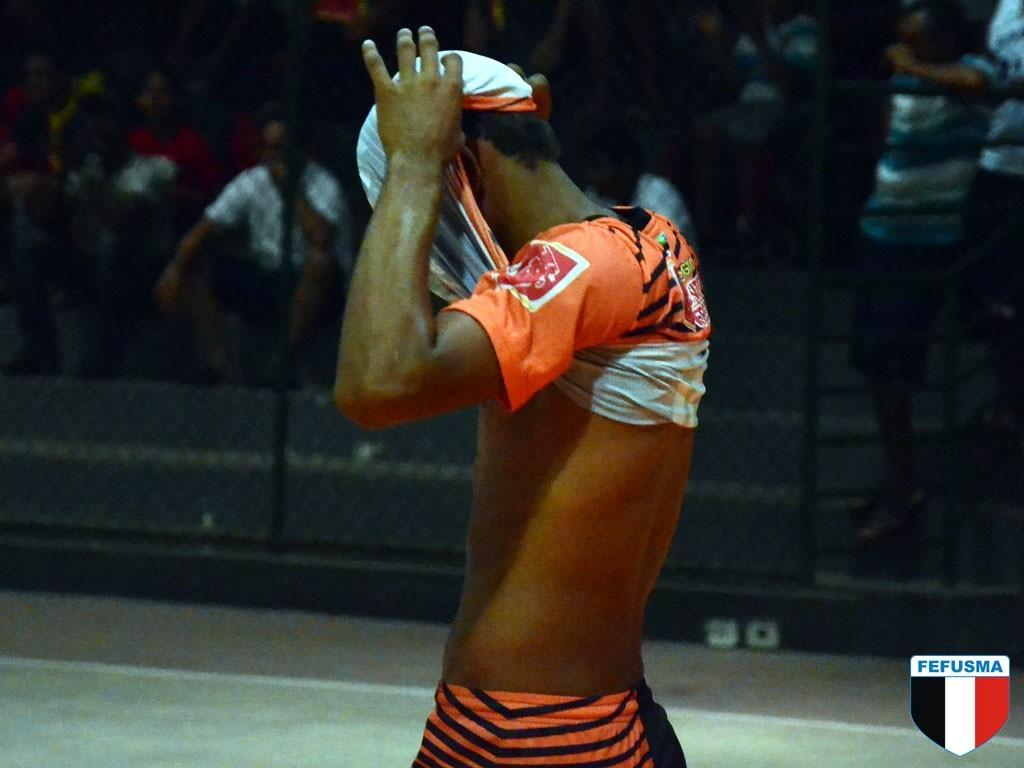Provide a one-sentence caption for the provided image. A man pulls his shirt over his head at a Fefusma game. 